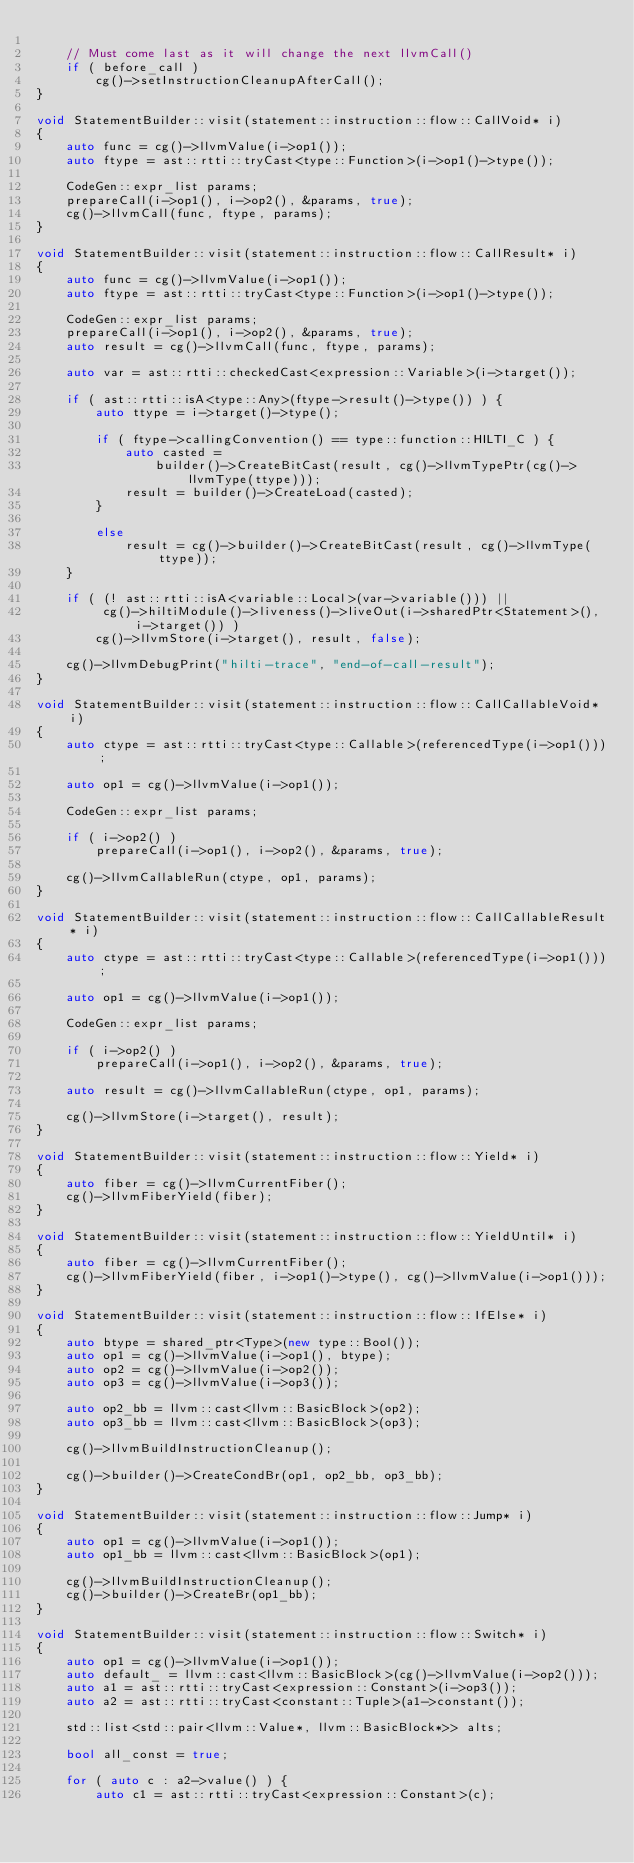<code> <loc_0><loc_0><loc_500><loc_500><_C++_>
    // Must come last as it will change the next llvmCall()
    if ( before_call )
        cg()->setInstructionCleanupAfterCall();
}

void StatementBuilder::visit(statement::instruction::flow::CallVoid* i)
{
    auto func = cg()->llvmValue(i->op1());
    auto ftype = ast::rtti::tryCast<type::Function>(i->op1()->type());

    CodeGen::expr_list params;
    prepareCall(i->op1(), i->op2(), &params, true);
    cg()->llvmCall(func, ftype, params);
}

void StatementBuilder::visit(statement::instruction::flow::CallResult* i)
{
    auto func = cg()->llvmValue(i->op1());
    auto ftype = ast::rtti::tryCast<type::Function>(i->op1()->type());

    CodeGen::expr_list params;
    prepareCall(i->op1(), i->op2(), &params, true);
    auto result = cg()->llvmCall(func, ftype, params);

    auto var = ast::rtti::checkedCast<expression::Variable>(i->target());

    if ( ast::rtti::isA<type::Any>(ftype->result()->type()) ) {
        auto ttype = i->target()->type();

        if ( ftype->callingConvention() == type::function::HILTI_C ) {
            auto casted =
                builder()->CreateBitCast(result, cg()->llvmTypePtr(cg()->llvmType(ttype)));
            result = builder()->CreateLoad(casted);
        }

        else
            result = cg()->builder()->CreateBitCast(result, cg()->llvmType(ttype));
    }

    if ( (! ast::rtti::isA<variable::Local>(var->variable())) ||
         cg()->hiltiModule()->liveness()->liveOut(i->sharedPtr<Statement>(), i->target()) )
        cg()->llvmStore(i->target(), result, false);

    cg()->llvmDebugPrint("hilti-trace", "end-of-call-result");
}

void StatementBuilder::visit(statement::instruction::flow::CallCallableVoid* i)
{
    auto ctype = ast::rtti::tryCast<type::Callable>(referencedType(i->op1()));

    auto op1 = cg()->llvmValue(i->op1());

    CodeGen::expr_list params;

    if ( i->op2() )
        prepareCall(i->op1(), i->op2(), &params, true);

    cg()->llvmCallableRun(ctype, op1, params);
}

void StatementBuilder::visit(statement::instruction::flow::CallCallableResult* i)
{
    auto ctype = ast::rtti::tryCast<type::Callable>(referencedType(i->op1()));

    auto op1 = cg()->llvmValue(i->op1());

    CodeGen::expr_list params;

    if ( i->op2() )
        prepareCall(i->op1(), i->op2(), &params, true);

    auto result = cg()->llvmCallableRun(ctype, op1, params);

    cg()->llvmStore(i->target(), result);
}

void StatementBuilder::visit(statement::instruction::flow::Yield* i)
{
    auto fiber = cg()->llvmCurrentFiber();
    cg()->llvmFiberYield(fiber);
}

void StatementBuilder::visit(statement::instruction::flow::YieldUntil* i)
{
    auto fiber = cg()->llvmCurrentFiber();
    cg()->llvmFiberYield(fiber, i->op1()->type(), cg()->llvmValue(i->op1()));
}

void StatementBuilder::visit(statement::instruction::flow::IfElse* i)
{
    auto btype = shared_ptr<Type>(new type::Bool());
    auto op1 = cg()->llvmValue(i->op1(), btype);
    auto op2 = cg()->llvmValue(i->op2());
    auto op3 = cg()->llvmValue(i->op3());

    auto op2_bb = llvm::cast<llvm::BasicBlock>(op2);
    auto op3_bb = llvm::cast<llvm::BasicBlock>(op3);

    cg()->llvmBuildInstructionCleanup();

    cg()->builder()->CreateCondBr(op1, op2_bb, op3_bb);
}

void StatementBuilder::visit(statement::instruction::flow::Jump* i)
{
    auto op1 = cg()->llvmValue(i->op1());
    auto op1_bb = llvm::cast<llvm::BasicBlock>(op1);

    cg()->llvmBuildInstructionCleanup();
    cg()->builder()->CreateBr(op1_bb);
}

void StatementBuilder::visit(statement::instruction::flow::Switch* i)
{
    auto op1 = cg()->llvmValue(i->op1());
    auto default_ = llvm::cast<llvm::BasicBlock>(cg()->llvmValue(i->op2()));
    auto a1 = ast::rtti::tryCast<expression::Constant>(i->op3());
    auto a2 = ast::rtti::tryCast<constant::Tuple>(a1->constant());

    std::list<std::pair<llvm::Value*, llvm::BasicBlock*>> alts;

    bool all_const = true;

    for ( auto c : a2->value() ) {
        auto c1 = ast::rtti::tryCast<expression::Constant>(c);</code> 